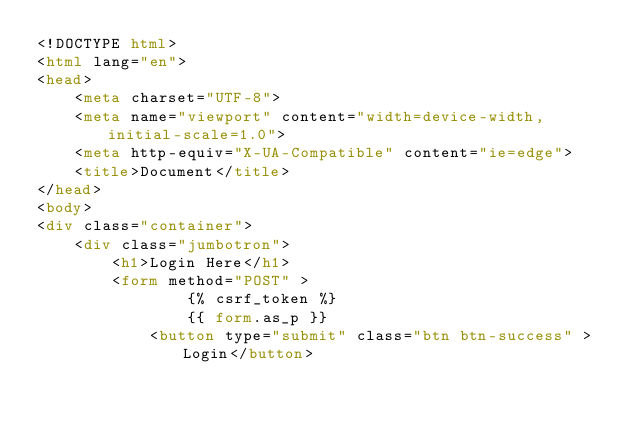Convert code to text. <code><loc_0><loc_0><loc_500><loc_500><_HTML_><!DOCTYPE html>
<html lang="en">
<head>
    <meta charset="UTF-8">
    <meta name="viewport" content="width=device-width, initial-scale=1.0">
    <meta http-equiv="X-UA-Compatible" content="ie=edge">
    <title>Document</title>
</head>
<body>
<div class="container">
    <div class="jumbotron">
        <h1>Login Here</h1>
        <form method="POST" >
                {% csrf_token %}
                {{ form.as_p }}
            <button type="submit" class="btn btn-success" >Login</button></code> 